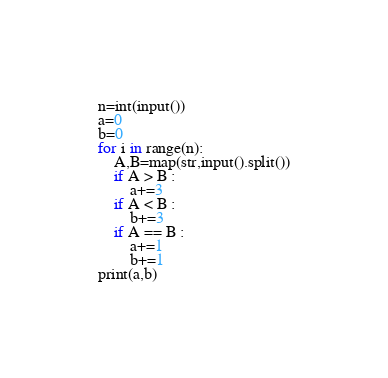<code> <loc_0><loc_0><loc_500><loc_500><_Python_>n=int(input())
a=0
b=0
for i in range(n):
    A,B=map(str,input().split())
    if A > B :
        a+=3
    if A < B :
        b+=3
    if A == B :
        a+=1
        b+=1
print(a,b)
</code> 